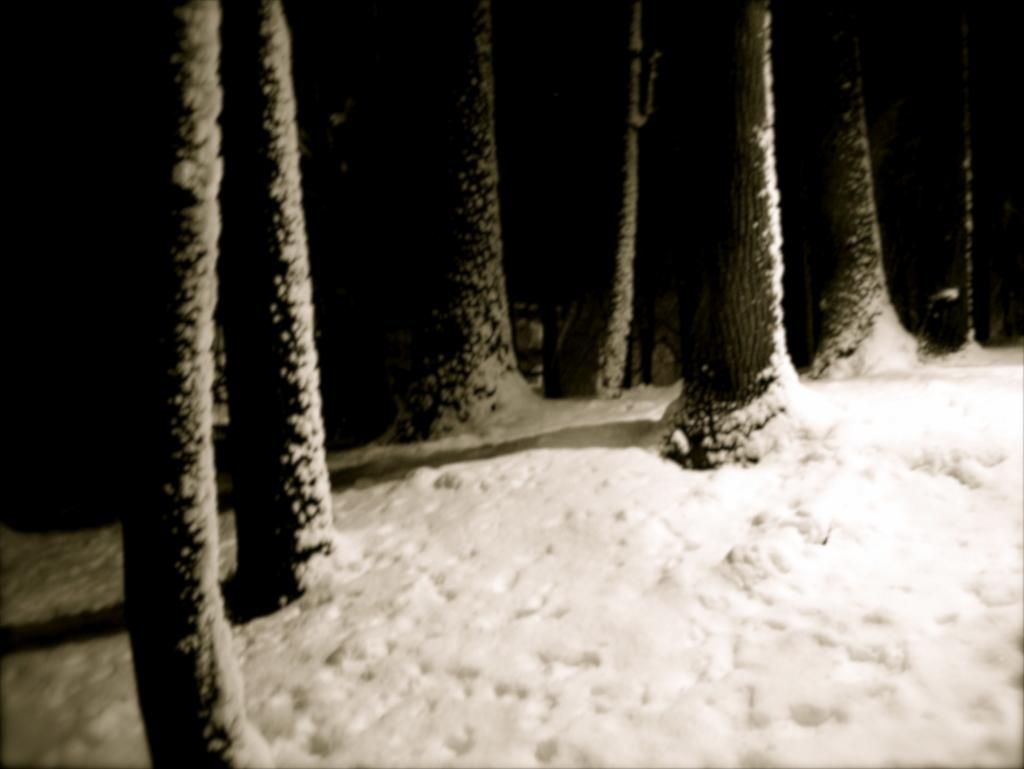What type of vegetation is present in the image? There are trunks of trees in the image. What is the weather condition in the image? There is snow visible in the image. How would you describe the overall lighting in the image? The background of the image is dark. What type of interest is being paid on the tree trunks in the image? There is no mention of interest or financial transactions in the image; it features tree trunks and snow. 